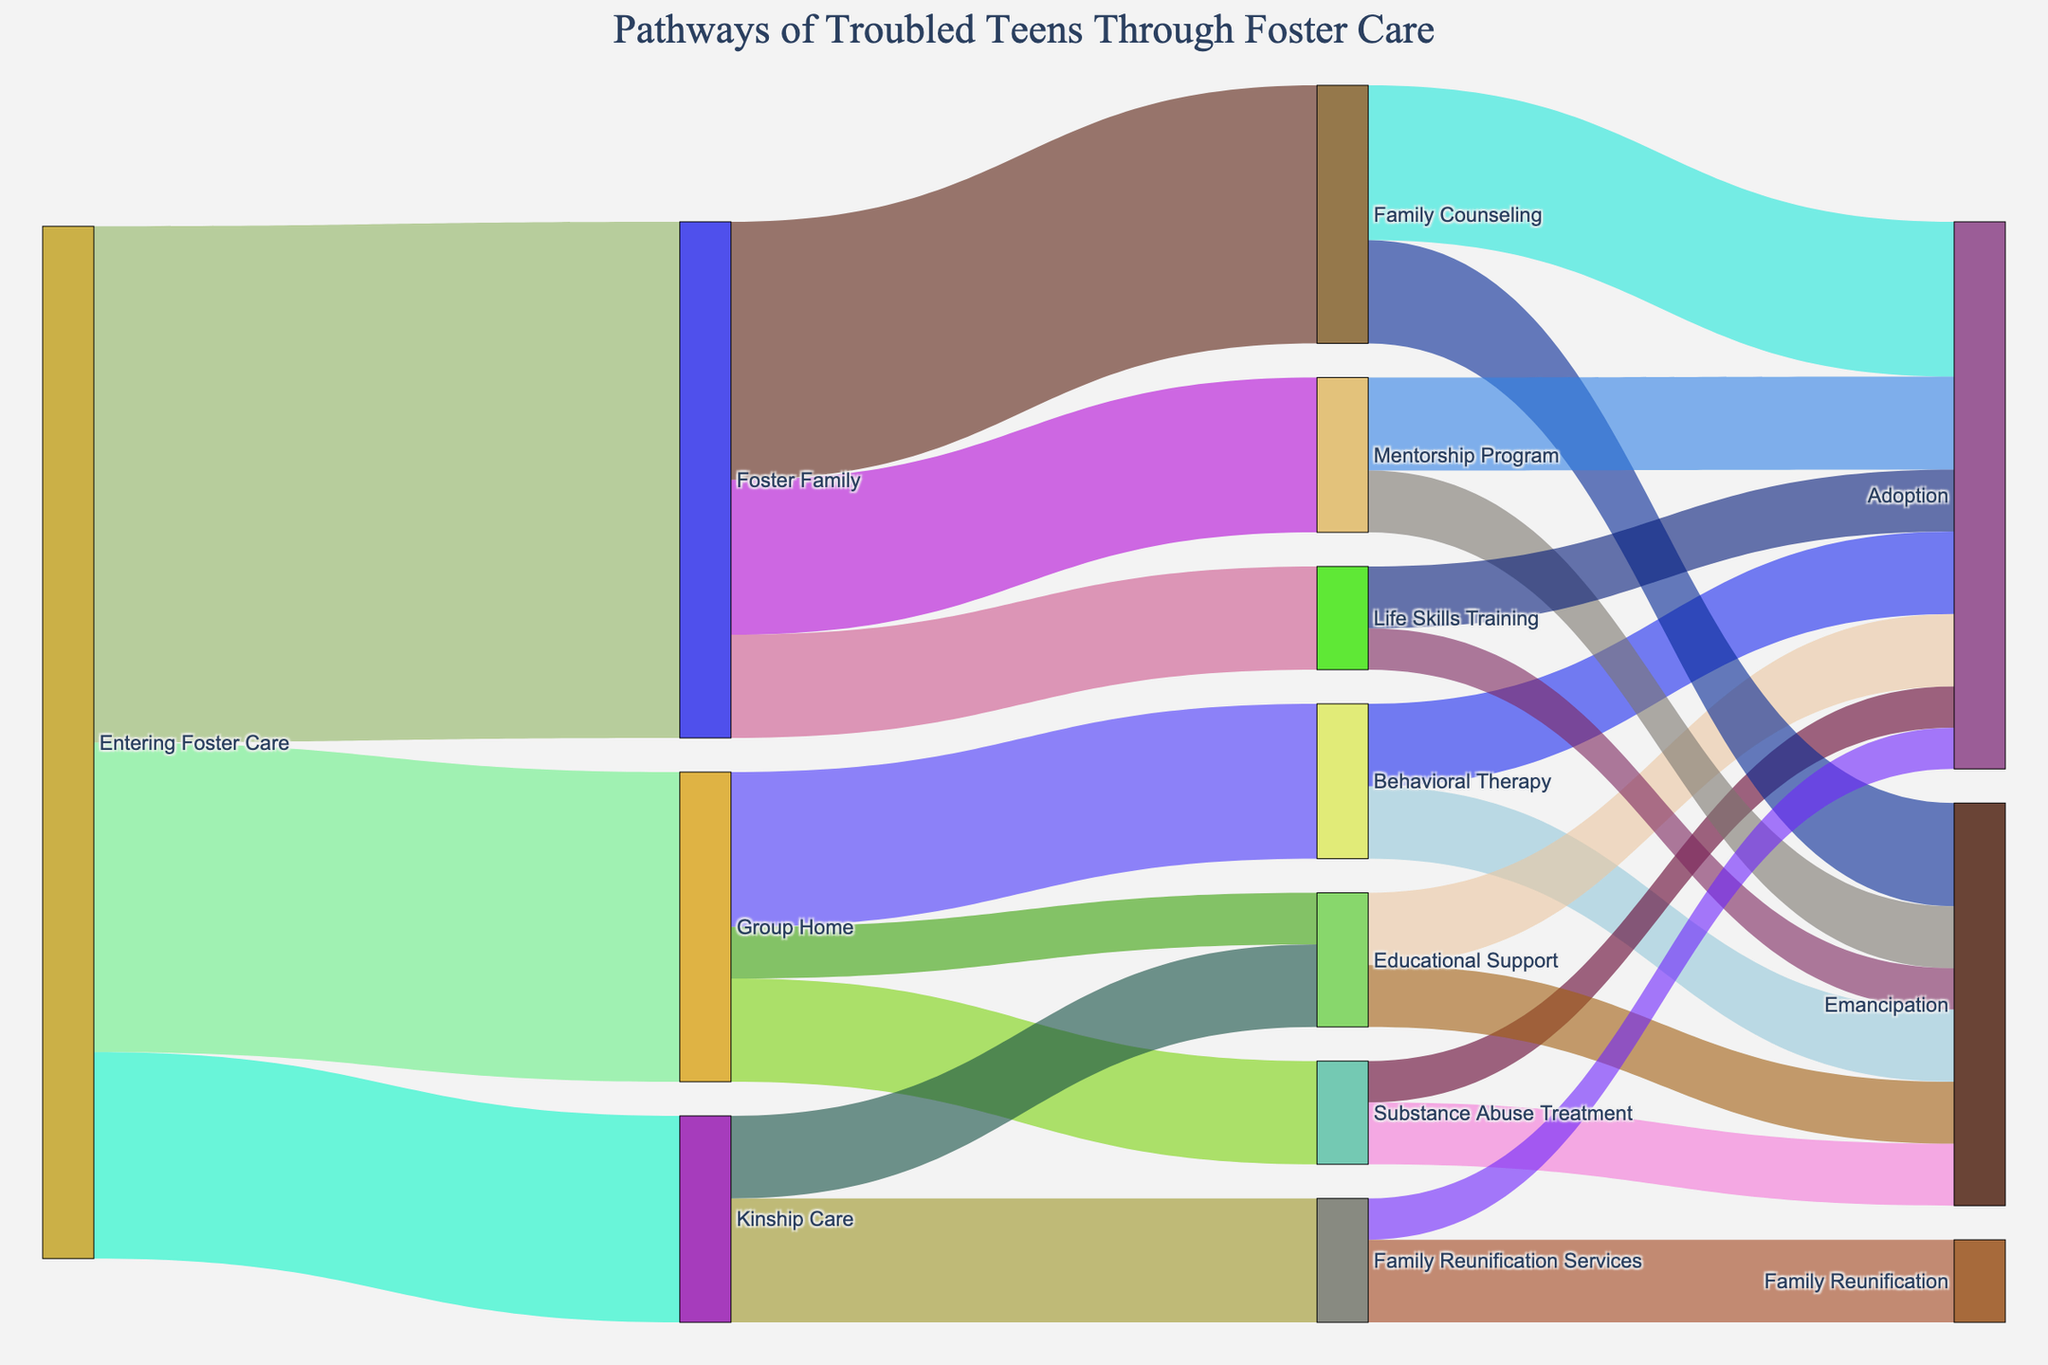How many troubled teens were placed in foster families upon entering foster care? To find this, look at the Sankey diagram's first segment where "Entering Foster Care" connects to "Foster Family." The value on this link indicates the number of troubled teens.
Answer: 50 Which intervention has the highest number of troubled teens coming from group homes? Examine the Sankey diagram sections connected to "Group Home." Compare "Behavioral Therapy," "Substance Abuse Treatment," and "Educational Support" and identify the highest value.
Answer: Behavioral Therapy After receiving family counseling, how many troubled teens were adopted? Observe the link between "Family Counseling" and "Adoption" in the Sankey diagram. The value on this link represents the number of adoptions.
Answer: 15 Which two interventions from foster families resulted in the highest numbers of adoptions and emancipations combined? Check the links from "Foster Family" to different interventions and sum the numbers of adoptions and emancipations for each. The two interventions with the highest combined totals are listed.
Answer: Family Counseling and Mentorship Program What is the total number of troubled teens who went through some form of educational support? Sum the values of troubled teens connecting to and from "Educational Support" in the diagram (group homes to educational support + kinship care to educational support).
Answer: 13 Compare the number of troubled teens going through kinship care versus foster family. Which has more, and by how much? Compare the values of the links from "Entering Foster Care" to "Kinship Care" and "Foster Family." The difference is calculated by subtraction.
Answer: Foster Family by 30 How many teens in group homes received substance abuse treatment? Check the link between "Group Home" and "Substance Abuse Treatment." The value on this link is the number of teens who received the treatment.
Answer: 10 What is the next most common outcome after behavioral therapy, aside from adoption? Look at the links from "Behavioral Therapy" and compare "Adoption" and "Emancipation." The next value would be the second highest number.
Answer: Emancipation What proportion of troubled teens from kinship care went through family reunification services? Divide the number of troubled teens from "Kinship Care" to "Family Reunification Services" by the total number of troubled teens into kinship care.
Answer: 12/20 